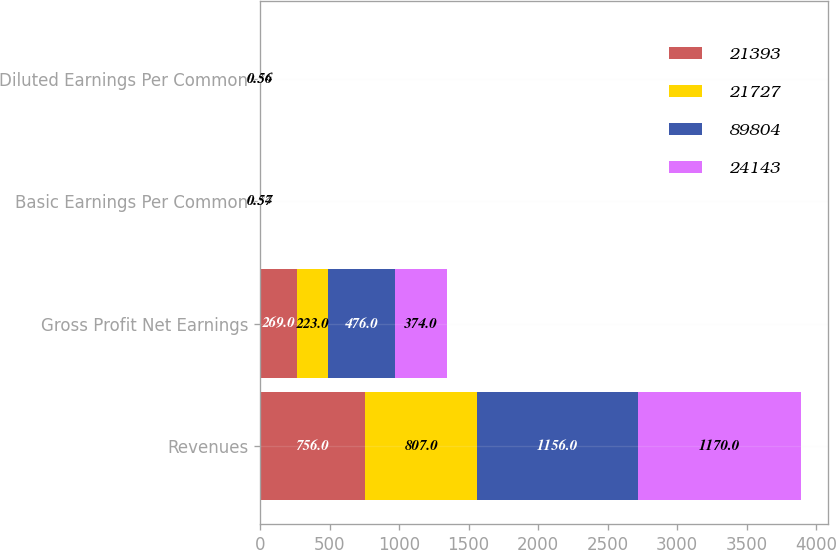Convert chart. <chart><loc_0><loc_0><loc_500><loc_500><stacked_bar_chart><ecel><fcel>Revenues<fcel>Gross Profit Net Earnings<fcel>Basic Earnings Per Common<fcel>Diluted Earnings Per Common<nl><fcel>21393<fcel>756<fcel>269<fcel>0.41<fcel>0.41<nl><fcel>21727<fcel>807<fcel>223<fcel>0.34<fcel>0.34<nl><fcel>89804<fcel>1156<fcel>476<fcel>0.72<fcel>0.72<nl><fcel>24143<fcel>1170<fcel>374<fcel>0.57<fcel>0.56<nl></chart> 